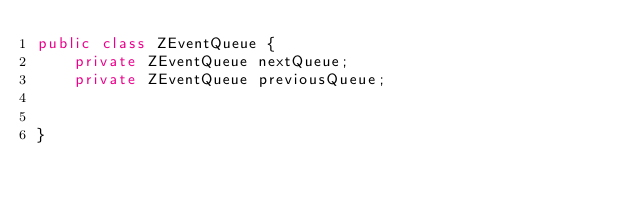Convert code to text. <code><loc_0><loc_0><loc_500><loc_500><_Java_>public class ZEventQueue {
    private ZEventQueue nextQueue;
    private ZEventQueue previousQueue;


}
</code> 